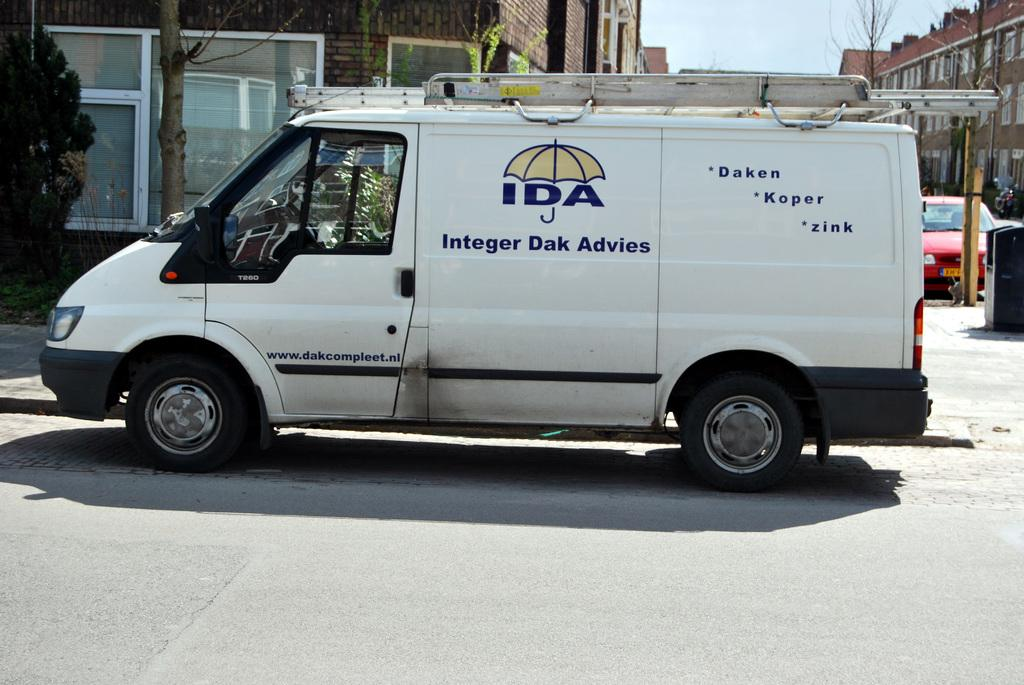What type of structures can be seen in the image? There are buildings in the image. What other natural elements are present in the image? There are trees in the image. What vehicles can be seen on the road in the image? There is a van and a car on the road in the image. How would you describe the weather based on the image? The sky is cloudy in the image. What historical event is being commemorated by the stick in the image? There is no stick present in the image, and therefore no historical event can be associated with it. 